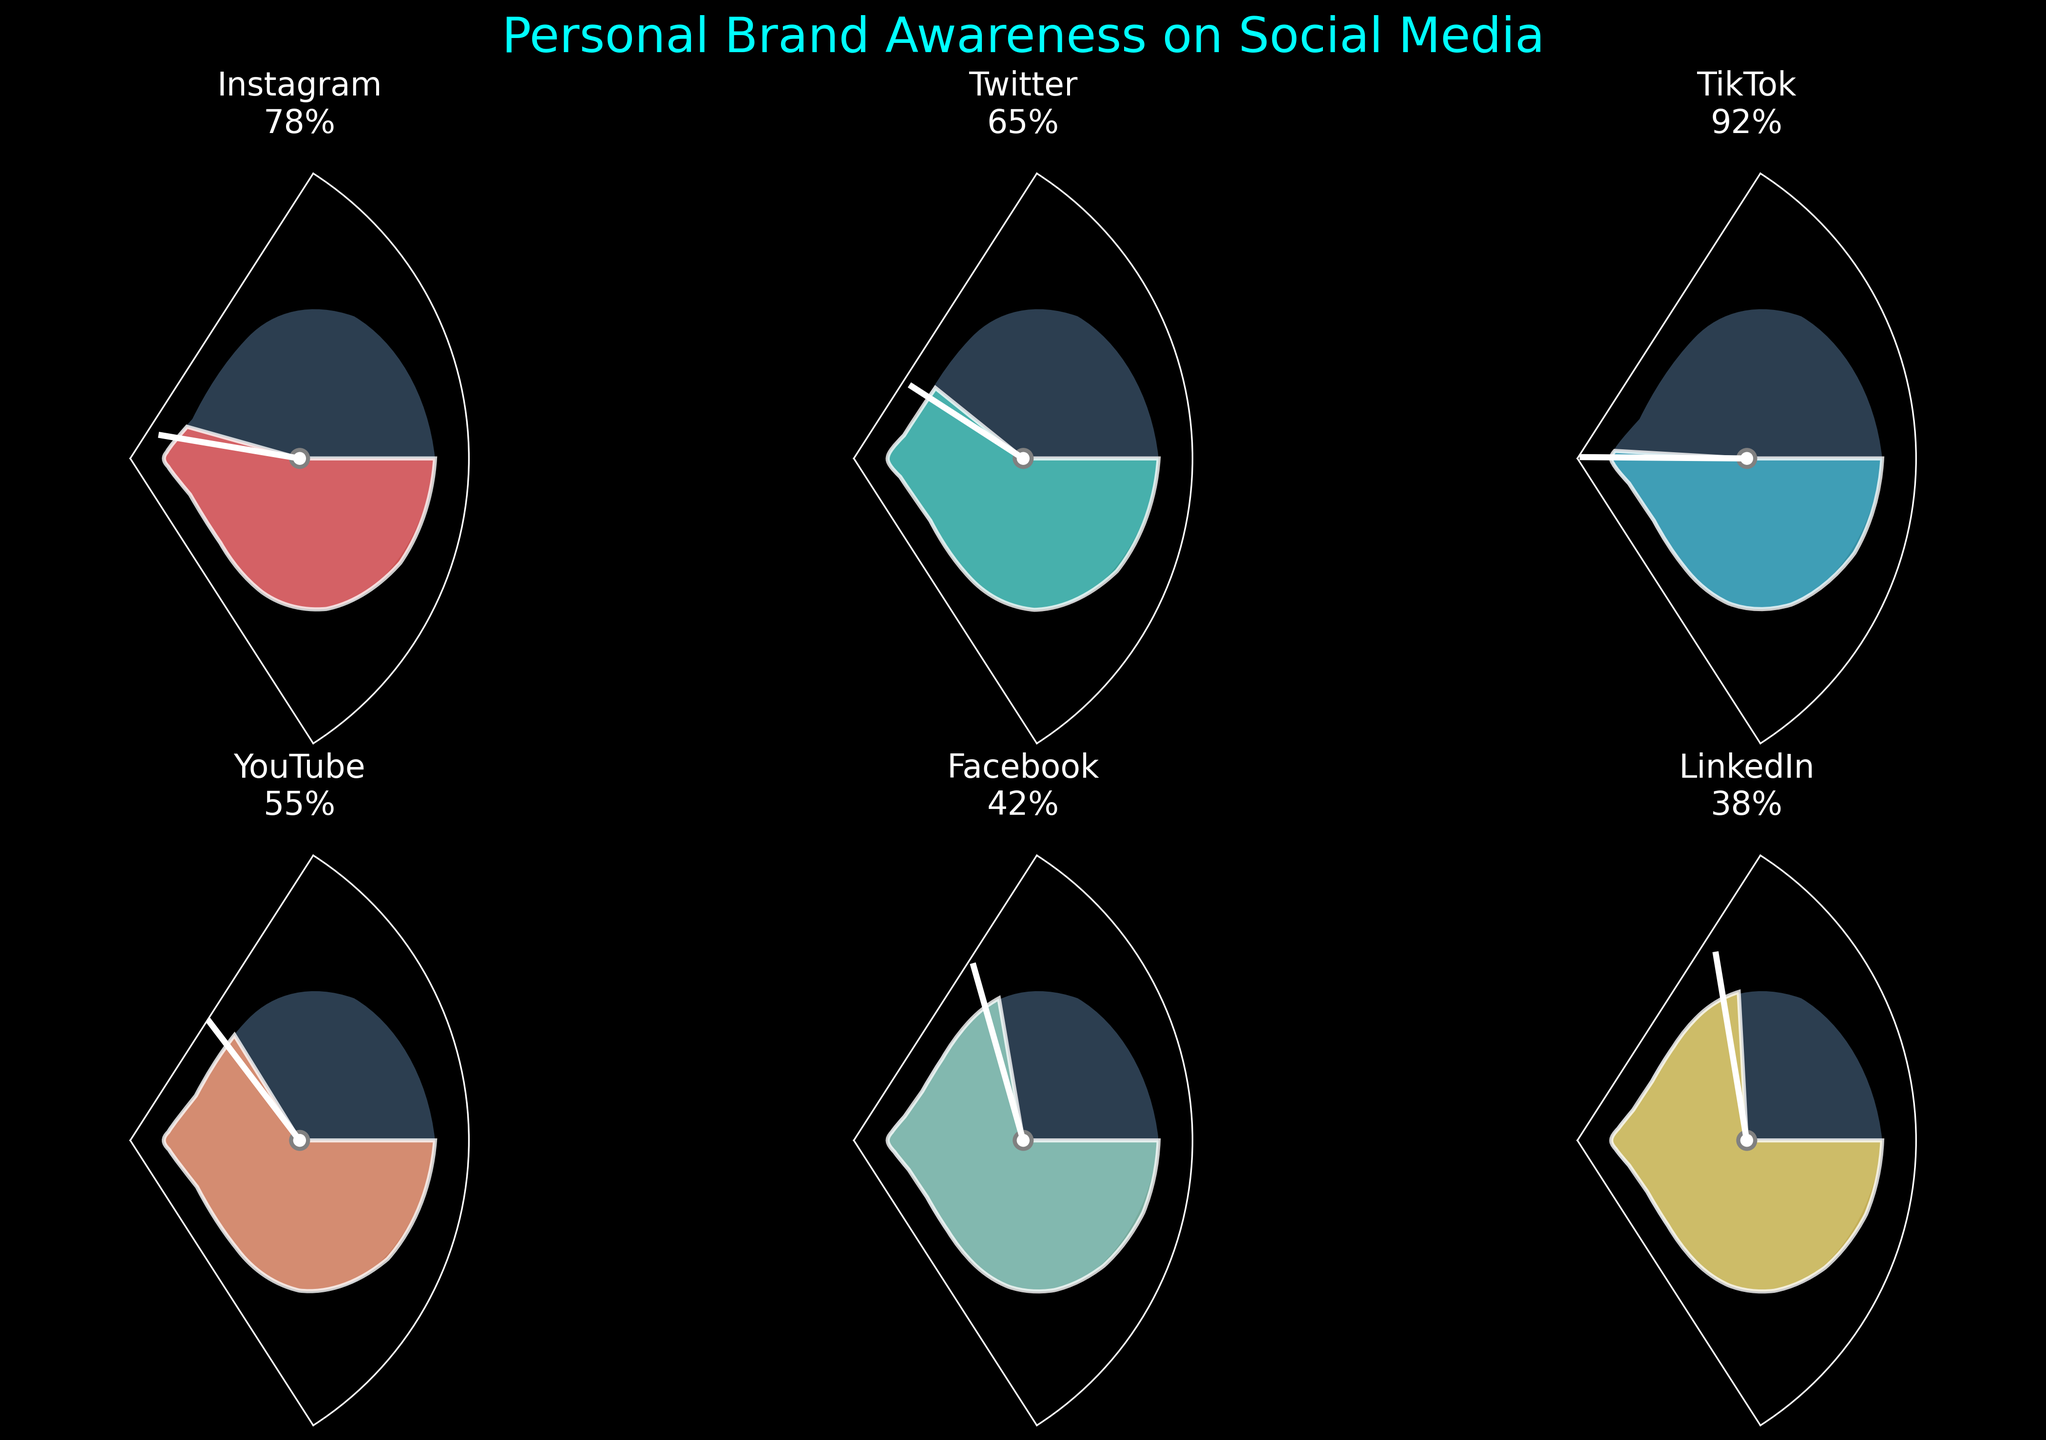What is the brand awareness score for TikTok? By looking at the gauge chart for TikTok, we can directly see the score given.
Answer: 92% Which social media platform has the lowest brand awareness score? We examine all the gauges to see which one has the smallest score.
Answer: LinkedIn What's the total brand awareness score across all platforms? We sum all the individual scores: 78 (Instagram) + 65 (Twitter) + 92 (TikTok) + 55 (YouTube) + 42 (Facebook) + 38 (LinkedIn). This is 370.
Answer: 370 How much higher is TikTok's score than YouTube's? Subtract the brand awareness score of YouTube from TikTok: 92 - 55.
Answer: 37 Which platform has a higher awareness score, Instagram or Facebook? Directly compare the two scores given for Instagram and Facebook.
Answer: Instagram What is the highest brand awareness score depicted in the figure? Find the largest score among all the gauges shown.
Answer: 92% (TikTok) What's the average brand awareness score across all social media platforms? Calculate the average by summing all the scores (370) divided by the number of platforms (6). 370 / 6 = 61.67.
Answer: 61.67% If we consider a score of 60% as the threshold for adequate brand awareness, which platforms surpass this threshold? Identify all platforms with scores above 60%: Instagram (78), Twitter (65), TikTok (92).
Answer: Instagram, Twitter, TikTok Which platform is closest to the median score? First, arrange the scores in order: 38, 42, 55, 65, 78, 92. The median of these six values is the average of the 3rd and 4th values: (55 + 65) / 2 = 60. The closest platform to this is Twitter with a score of 65.
Answer: Twitter What is the difference between the highest and lowest brand awareness scores? Subtract the lowest score from the highest score: 92 (highest) - 38 (lowest).
Answer: 54 